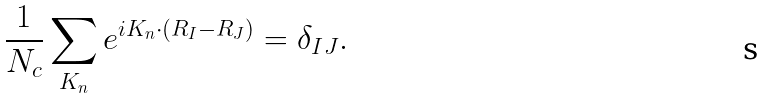Convert formula to latex. <formula><loc_0><loc_0><loc_500><loc_500>\frac { 1 } { N _ { c } } \sum _ { K _ { n } } e ^ { i K _ { n } \cdot ( R _ { I } - R _ { J } ) } = \delta _ { I J } .</formula> 